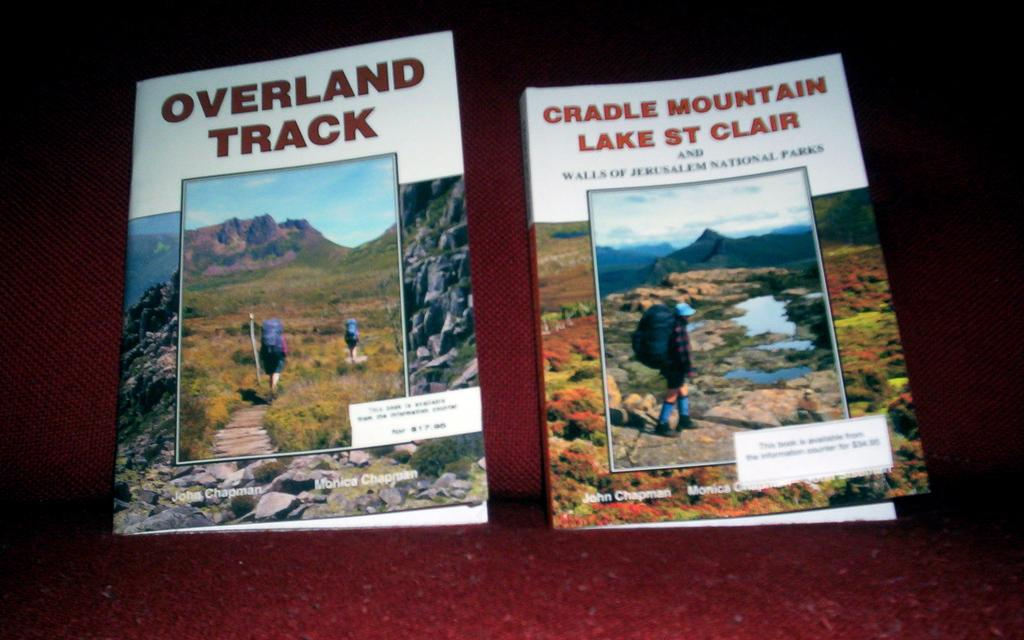Provide a one-sentence caption for the provided image. The book "Overland Track" next to the book "Cradle Mountain Lake St Clair". 